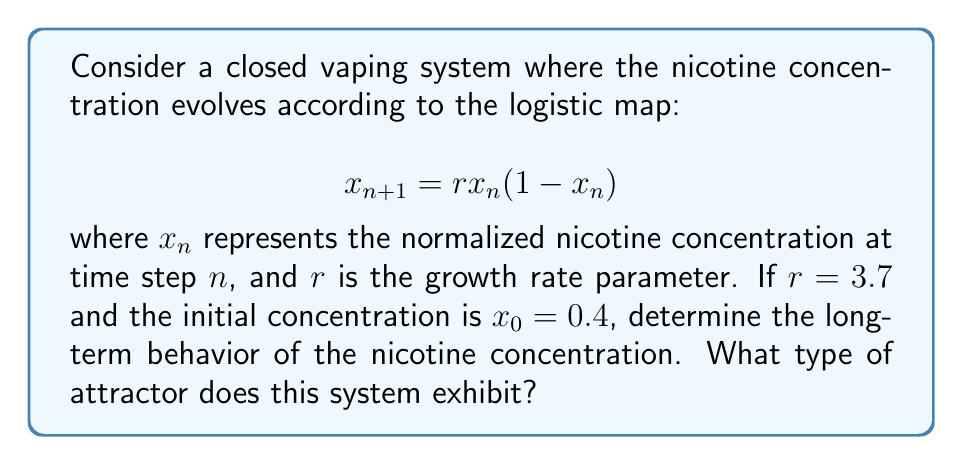Could you help me with this problem? To analyze the long-term behavior of this system, we need to iterate the logistic map equation and observe the pattern:

1) First, let's calculate the first few iterations:
   $x_1 = 3.7 \cdot 0.4 \cdot (1-0.4) = 0.888$
   $x_2 = 3.7 \cdot 0.888 \cdot (1-0.888) \approx 0.3684$
   $x_3 = 3.7 \cdot 0.3684 \cdot (1-0.3684) \approx 0.8614$
   $x_4 = 3.7 \cdot 0.8614 \cdot (1-0.8614) \approx 0.4424$

2) Continuing this process for many iterations, we observe that the values do not settle into a fixed point or a simple periodic cycle.

3) For $r = 3.7$, the logistic map is known to exhibit chaotic behavior. This means that the long-term evolution of the nicotine concentration will be aperiodic and sensitive to initial conditions.

4) To visualize this, we can create a bifurcation diagram:

[asy]
import graph;
size(200,150);
real f(real x, real r) {return r*x*(1-x);}
for(real r=2.5; r<=4; r+=0.005) {
  real x=0.5;
  for(int i=0; i<1000; ++i) {
    x=f(x,r);
    if(i>100) dot((r,x),red+0.1pt);
  }
}
xaxis("r",2.5,4,Arrow);
yaxis("x",0,1,Arrow);
[/asy]

5) At $r = 3.7$, we can see that the system exhibits a strange attractor, which is characteristic of chaotic systems.

6) This chaotic behavior implies that small variations in the initial concentration or system parameters can lead to significantly different long-term outcomes, making precise long-term predictions impossible.
Answer: Chaotic strange attractor 